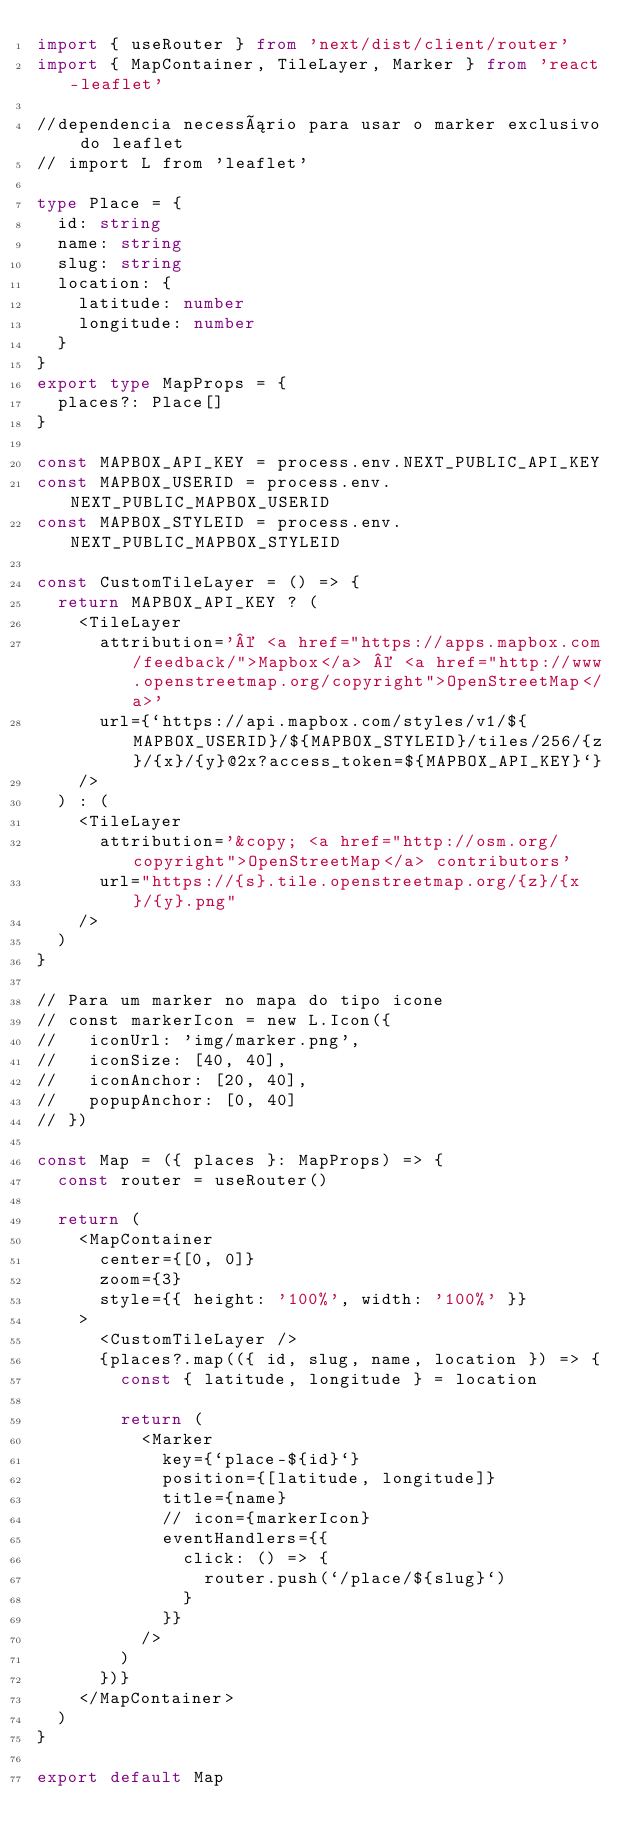<code> <loc_0><loc_0><loc_500><loc_500><_TypeScript_>import { useRouter } from 'next/dist/client/router'
import { MapContainer, TileLayer, Marker } from 'react-leaflet'

//dependencia necessário para usar o marker exclusivo do leaflet
// import L from 'leaflet'

type Place = {
  id: string
  name: string
  slug: string
  location: {
    latitude: number
    longitude: number
  }
}
export type MapProps = {
  places?: Place[]
}

const MAPBOX_API_KEY = process.env.NEXT_PUBLIC_API_KEY
const MAPBOX_USERID = process.env.NEXT_PUBLIC_MAPBOX_USERID
const MAPBOX_STYLEID = process.env.NEXT_PUBLIC_MAPBOX_STYLEID

const CustomTileLayer = () => {
  return MAPBOX_API_KEY ? (
    <TileLayer
      attribution='© <a href="https://apps.mapbox.com/feedback/">Mapbox</a> © <a href="http://www.openstreetmap.org/copyright">OpenStreetMap</a>'
      url={`https://api.mapbox.com/styles/v1/${MAPBOX_USERID}/${MAPBOX_STYLEID}/tiles/256/{z}/{x}/{y}@2x?access_token=${MAPBOX_API_KEY}`}
    />
  ) : (
    <TileLayer
      attribution='&copy; <a href="http://osm.org/copyright">OpenStreetMap</a> contributors'
      url="https://{s}.tile.openstreetmap.org/{z}/{x}/{y}.png"
    />
  )
}

// Para um marker no mapa do tipo icone
// const markerIcon = new L.Icon({
//   iconUrl: 'img/marker.png',
//   iconSize: [40, 40],
//   iconAnchor: [20, 40],
//   popupAnchor: [0, 40]
// })

const Map = ({ places }: MapProps) => {
  const router = useRouter()

  return (
    <MapContainer
      center={[0, 0]}
      zoom={3}
      style={{ height: '100%', width: '100%' }}
    >
      <CustomTileLayer />
      {places?.map(({ id, slug, name, location }) => {
        const { latitude, longitude } = location

        return (
          <Marker
            key={`place-${id}`}
            position={[latitude, longitude]}
            title={name}
            // icon={markerIcon}
            eventHandlers={{
              click: () => {
                router.push(`/place/${slug}`)
              }
            }}
          />
        )
      })}
    </MapContainer>
  )
}

export default Map
</code> 